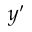<formula> <loc_0><loc_0><loc_500><loc_500>y ^ { \prime }</formula> 